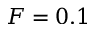Convert formula to latex. <formula><loc_0><loc_0><loc_500><loc_500>F = 0 . 1</formula> 